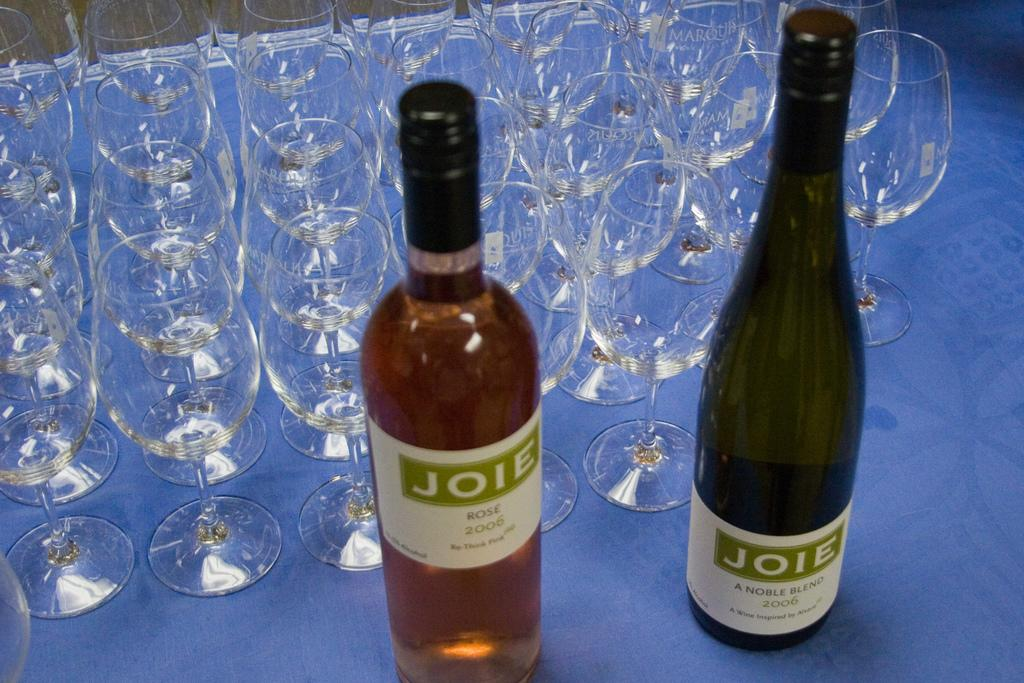Provide a one-sentence caption for the provided image. A rose and a white bottle of Joie wine sit unopened on a table next to dozens of empty and sprkling clean wine glasses. 